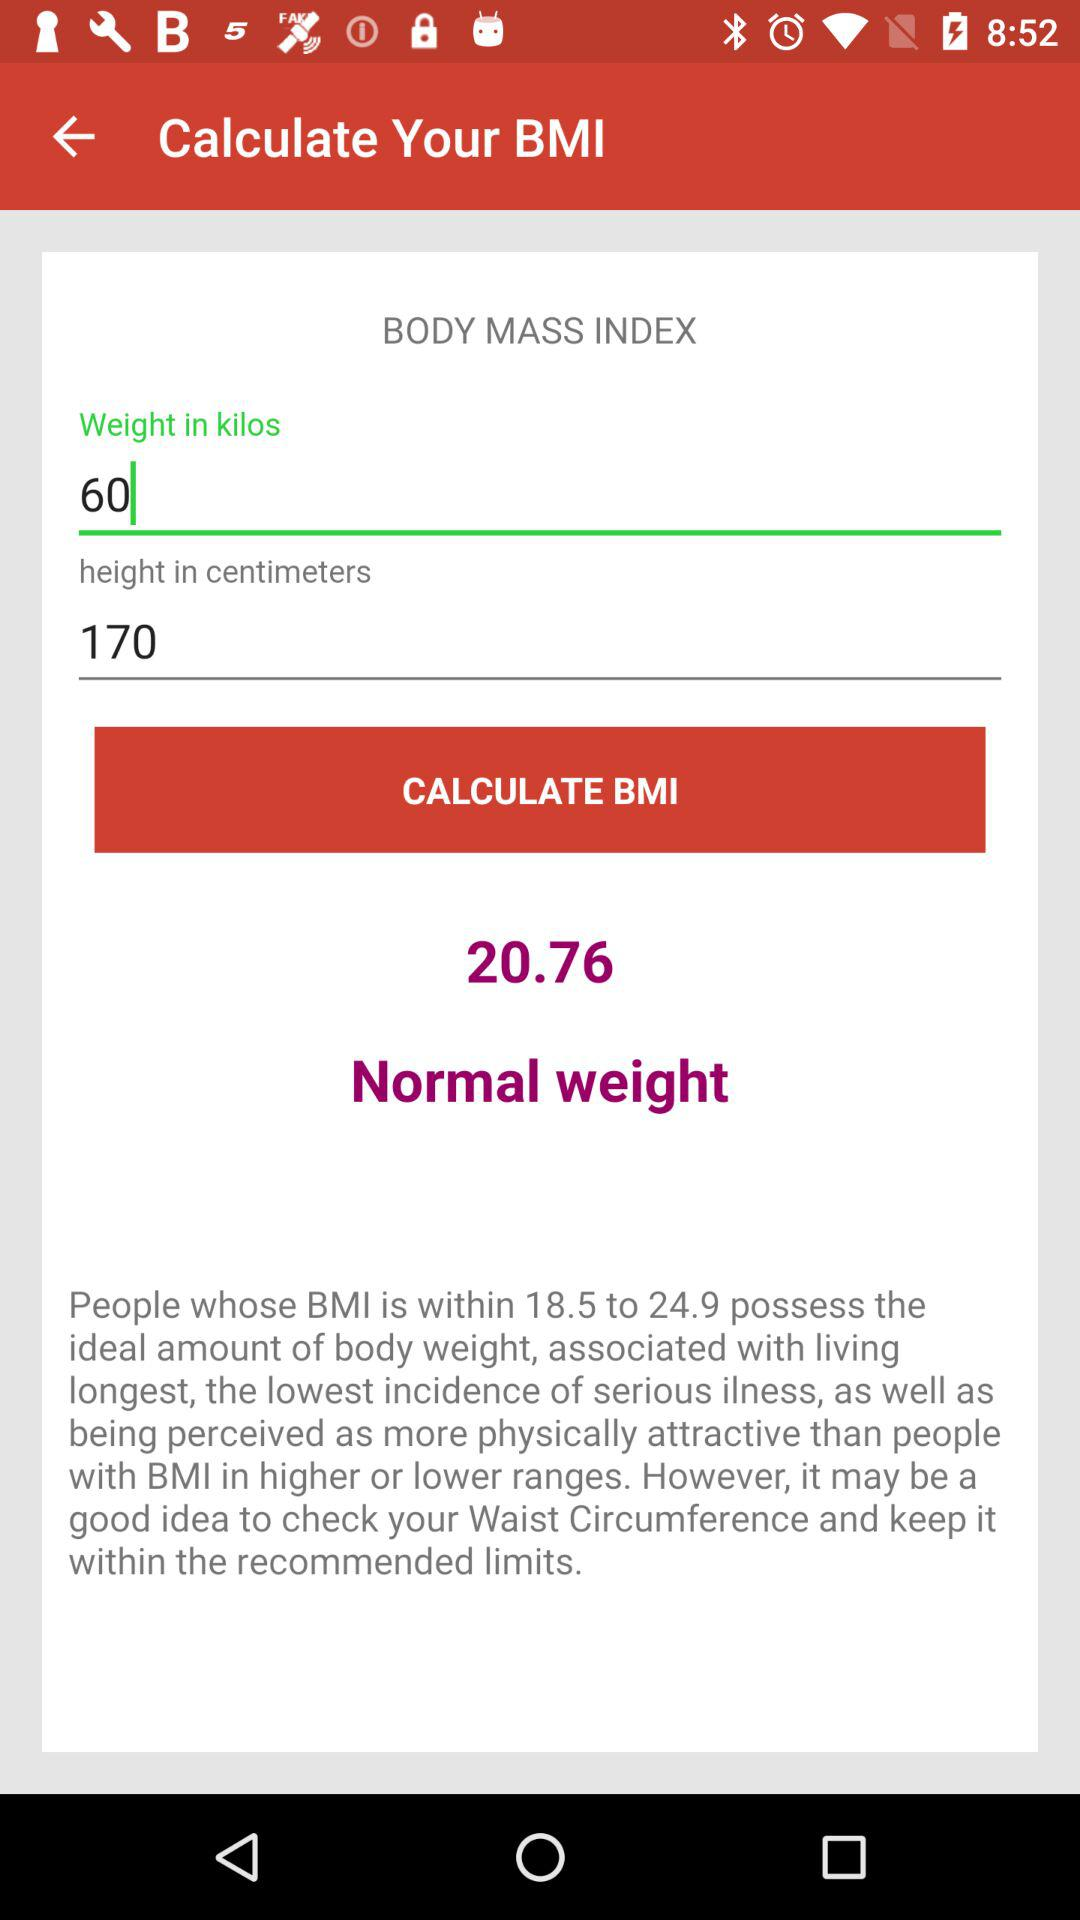What is the height? The height is 170 centimeters. 